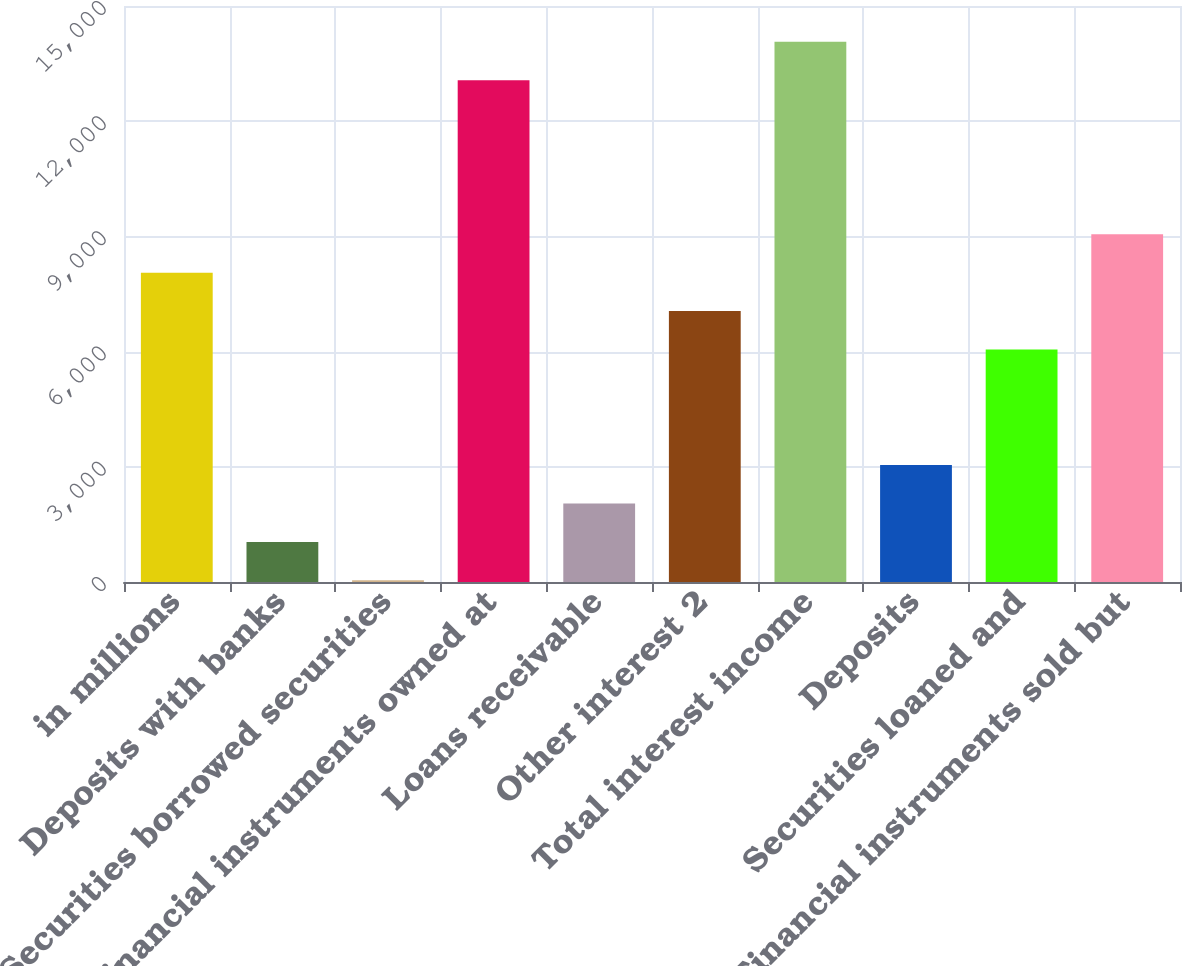<chart> <loc_0><loc_0><loc_500><loc_500><bar_chart><fcel>in millions<fcel>Deposits with banks<fcel>Securities borrowed securities<fcel>Financial instruments owned at<fcel>Loans receivable<fcel>Other interest 2<fcel>Total interest income<fcel>Deposits<fcel>Securities loaned and<fcel>Financial instruments sold but<nl><fcel>8056.6<fcel>1044.7<fcel>43<fcel>13065.1<fcel>2046.4<fcel>7054.9<fcel>14066.8<fcel>3048.1<fcel>6053.2<fcel>9058.3<nl></chart> 